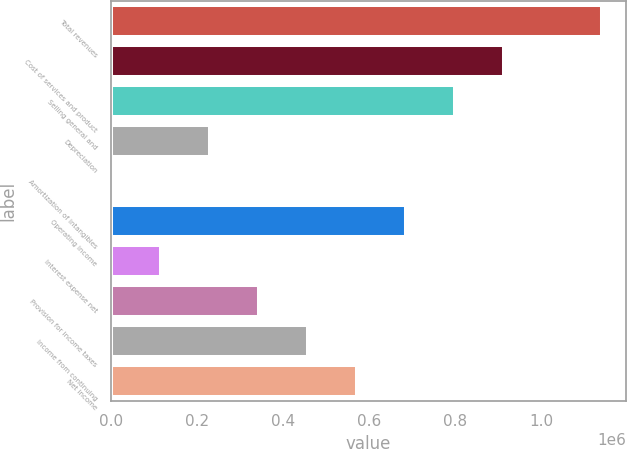<chart> <loc_0><loc_0><loc_500><loc_500><bar_chart><fcel>Total revenues<fcel>Cost of services and product<fcel>Selling general and<fcel>Depreciation<fcel>Amortization of intangibles<fcel>Operating income<fcel>Interest expense net<fcel>Provision for income taxes<fcel>Income from continuing<fcel>Net income<nl><fcel>1.1398e+06<fcel>912167<fcel>798351<fcel>229269<fcel>1636<fcel>684534<fcel>115452<fcel>343085<fcel>456902<fcel>570718<nl></chart> 